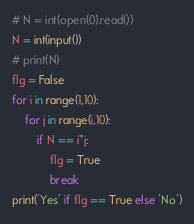Convert code to text. <code><loc_0><loc_0><loc_500><loc_500><_Python_># N = int(open(0).read())
N = int(input())
# print(N)
flg = False
for i in range(1,10):
    for j in range(i,10):
        if N == i*j:
            flg = True
            break
print('Yes' if flg == True else 'No')</code> 